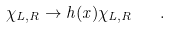<formula> <loc_0><loc_0><loc_500><loc_500>\chi _ { L , R } \to h ( x ) \chi _ { L , R } \quad .</formula> 